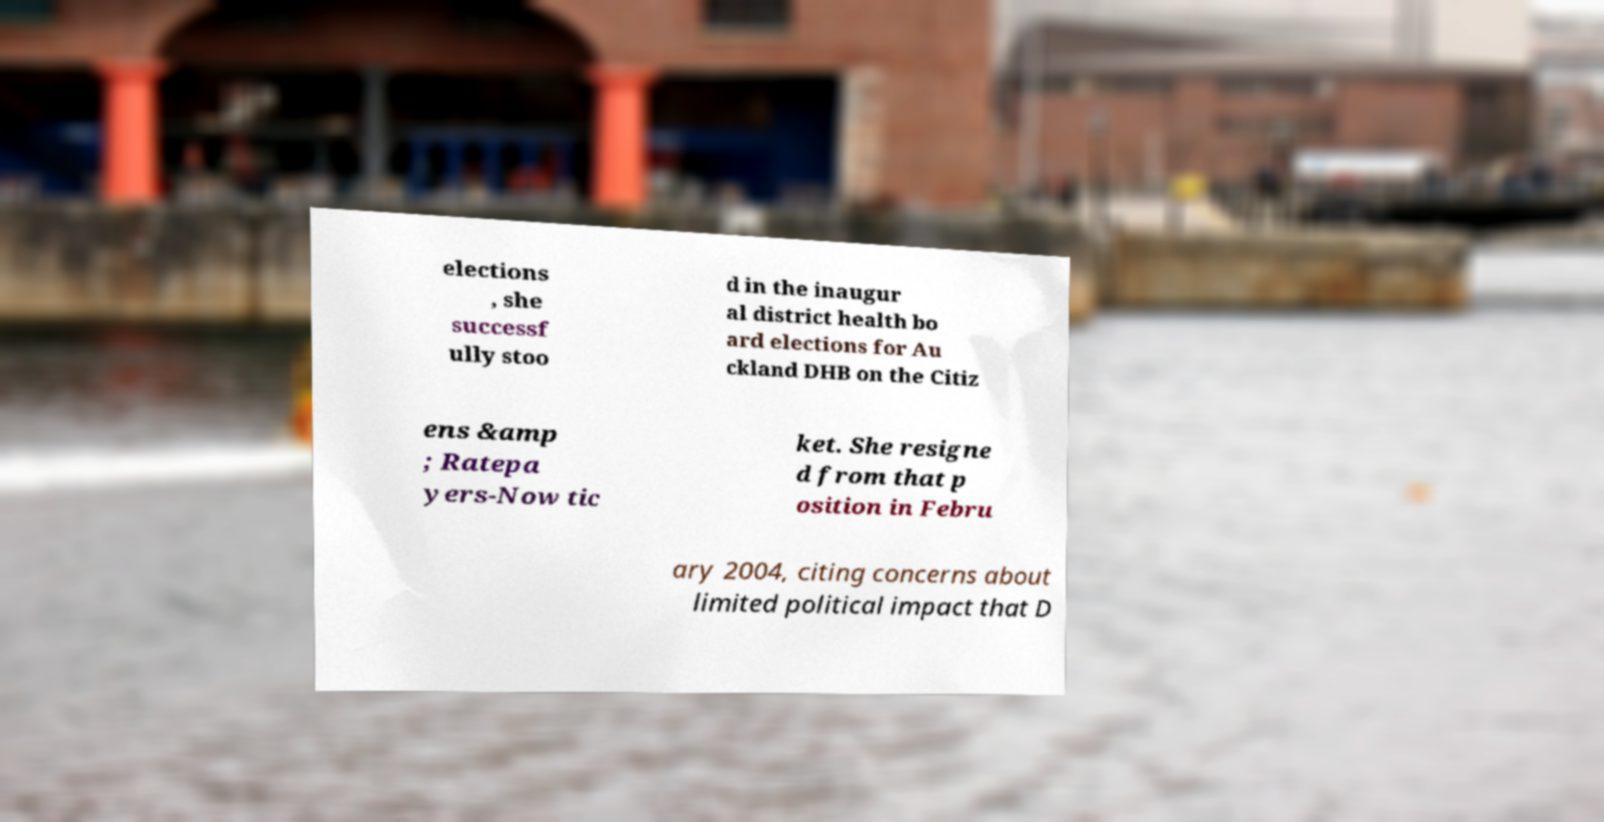Please read and relay the text visible in this image. What does it say? elections , she successf ully stoo d in the inaugur al district health bo ard elections for Au ckland DHB on the Citiz ens &amp ; Ratepa yers-Now tic ket. She resigne d from that p osition in Febru ary 2004, citing concerns about limited political impact that D 